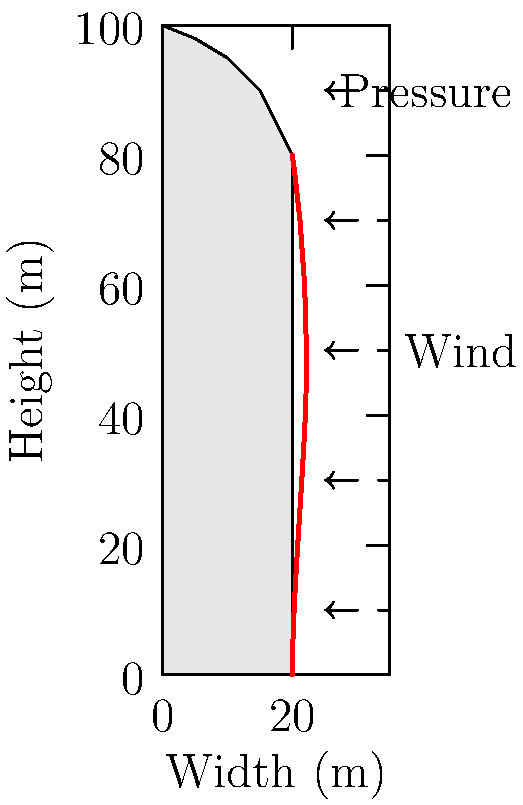You're mixing drinks at the club when a Civil Engineering student asks about wind pressure on high-rise buildings. Looking at the diagram of a uniquely shaped tower, what's the primary factor causing the non-uniform pressure distribution shown by the red line? Let's break this down step-by-step:

1. Building Shape: The tower has a unique shape, tapering at the top.

2. Wind Direction: The arrows show wind coming from the right side of the building.

3. Pressure Distribution: The red line represents the pressure distribution, which is not uniform along the height of the building.

4. Bernoulli's Principle: As wind speed increases, pressure decreases.

5. Wind Speed Variation: Wind speed generally increases with height due to less surface friction.

6. Shape Effect: The building's shape causes wind to accelerate around the curved top.

7. Pressure at Base: Lower wind speeds at the base result in higher pressure.

8. Pressure at Top: Higher wind speeds and curvature at the top lead to lower pressure.

9. Main Factor: The combination of increasing wind speed with height and the building's unique shape (especially the curved top) primarily causes the non-uniform pressure distribution.

The primary factor is the building's shape interacting with the vertical wind speed profile.
Answer: Building shape and wind speed profile interaction 